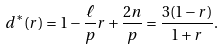<formula> <loc_0><loc_0><loc_500><loc_500>d ^ { * } ( r ) = 1 - \frac { \ell } { p } r + \frac { 2 n } { p } = \frac { 3 ( 1 - r ) } { 1 + r } .</formula> 